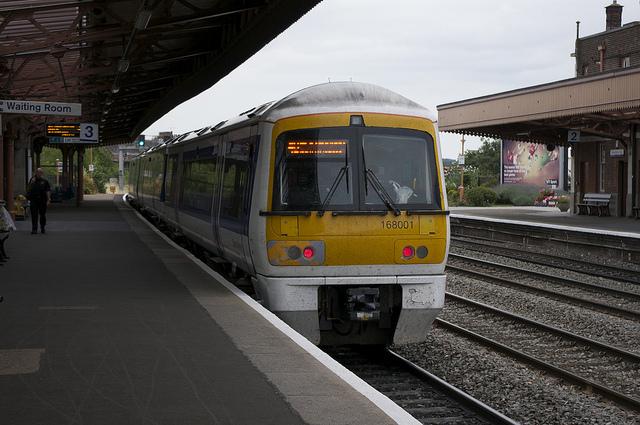Are both of the lights on?
Answer briefly. Yes. Is there grass next to the train?
Write a very short answer. No. Has the train stopped?
Keep it brief. Yes. Is this train in the station?
Write a very short answer. Yes. How many tracks are to the right of the train?
Keep it brief. 3. What platform is this?
Be succinct. Train. 